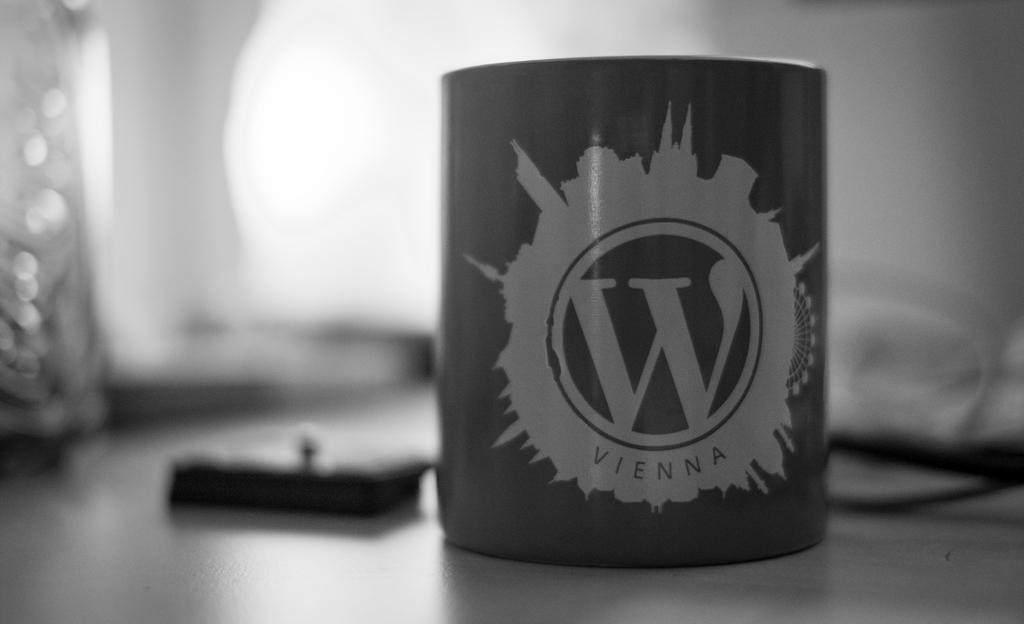What is the main object in the image? There is a coffee mug in the image. Where is the coffee mug placed? The coffee mug is placed on a surface. What else can be seen in the backdrop of the image? There is a water bottle and other objects on the table in the backdrop of the image. What type of linen is draped over the coffee mug in the image? There is no linen draped over the coffee mug in the image. How is the coal being used in the image? There is no coal present in the image. 